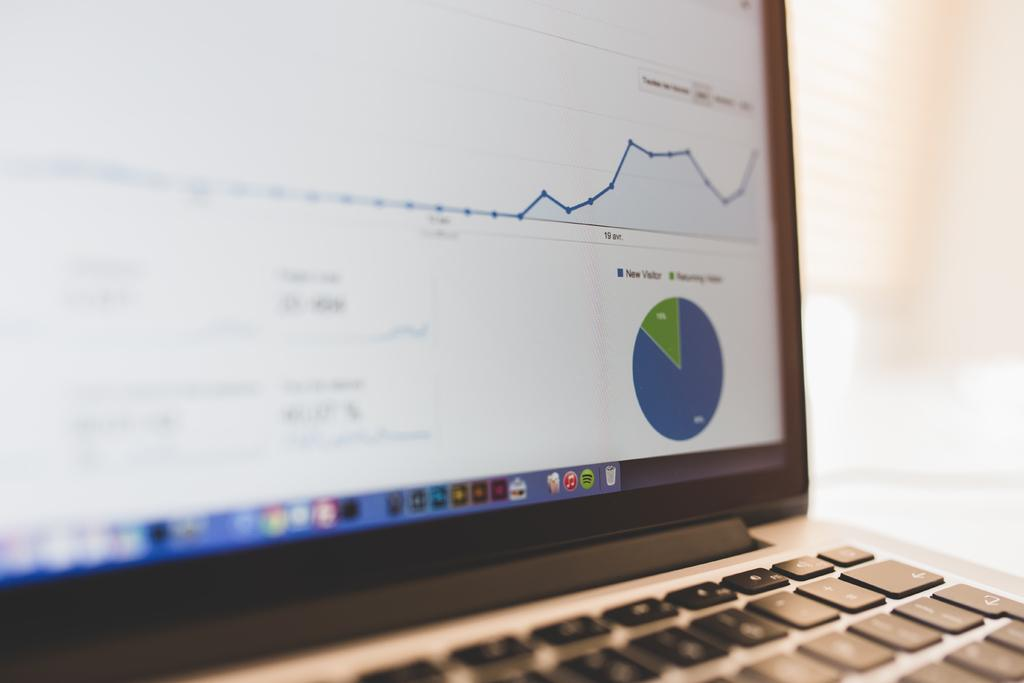Provide a one-sentence caption for the provided image. different graphs show information about new and returning visitors. 